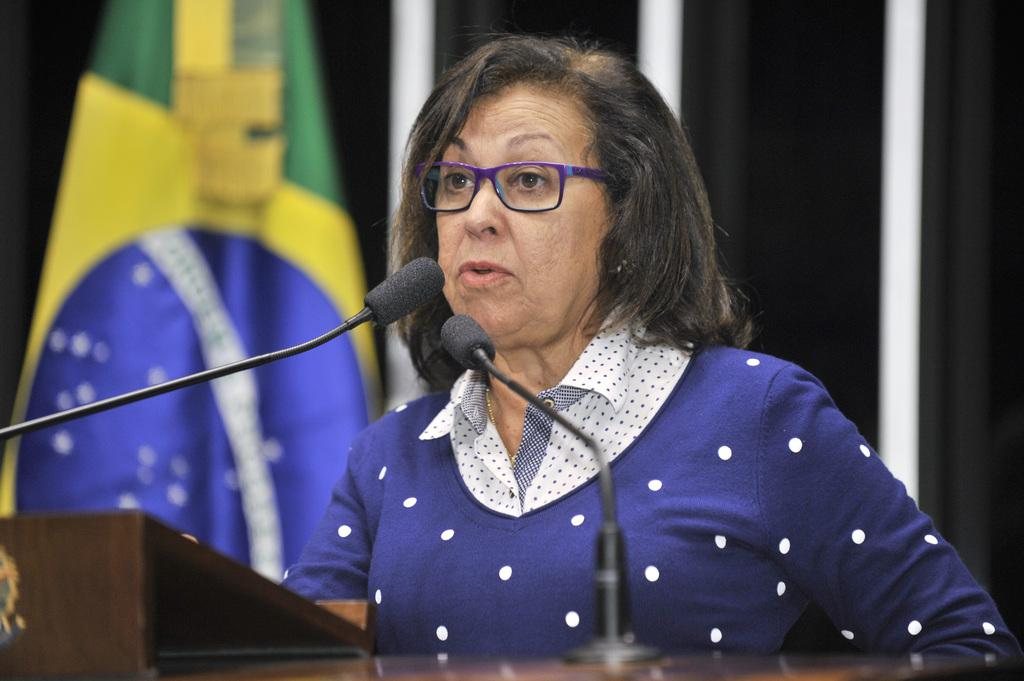Who is the main subject in the image? There is a woman in the image. What is the woman doing in the image? The woman is standing near a desk and talking into a microphone. What is the woman wearing in the image? The woman is wearing a blue dress. What can be seen in the background of the image? There is a wall behind the woman and a flag visible in the image. Can you tell me what type of toothbrush the woman is using in the image? There is no toothbrush present in the image; the woman is talking into a microphone. What are the woman's hobbies, as depicted in the image? The image does not provide information about the woman's hobbies; it only shows her standing near a desk and talking into a microphone. 